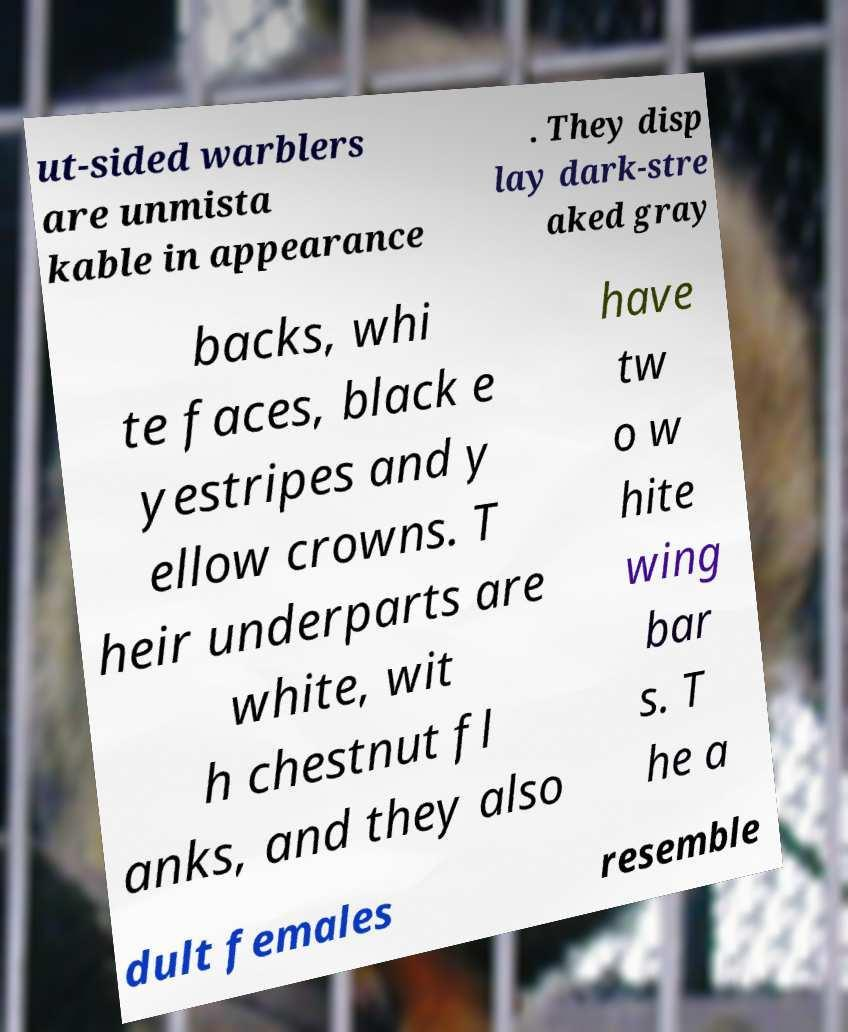Please identify and transcribe the text found in this image. ut-sided warblers are unmista kable in appearance . They disp lay dark-stre aked gray backs, whi te faces, black e yestripes and y ellow crowns. T heir underparts are white, wit h chestnut fl anks, and they also have tw o w hite wing bar s. T he a dult females resemble 